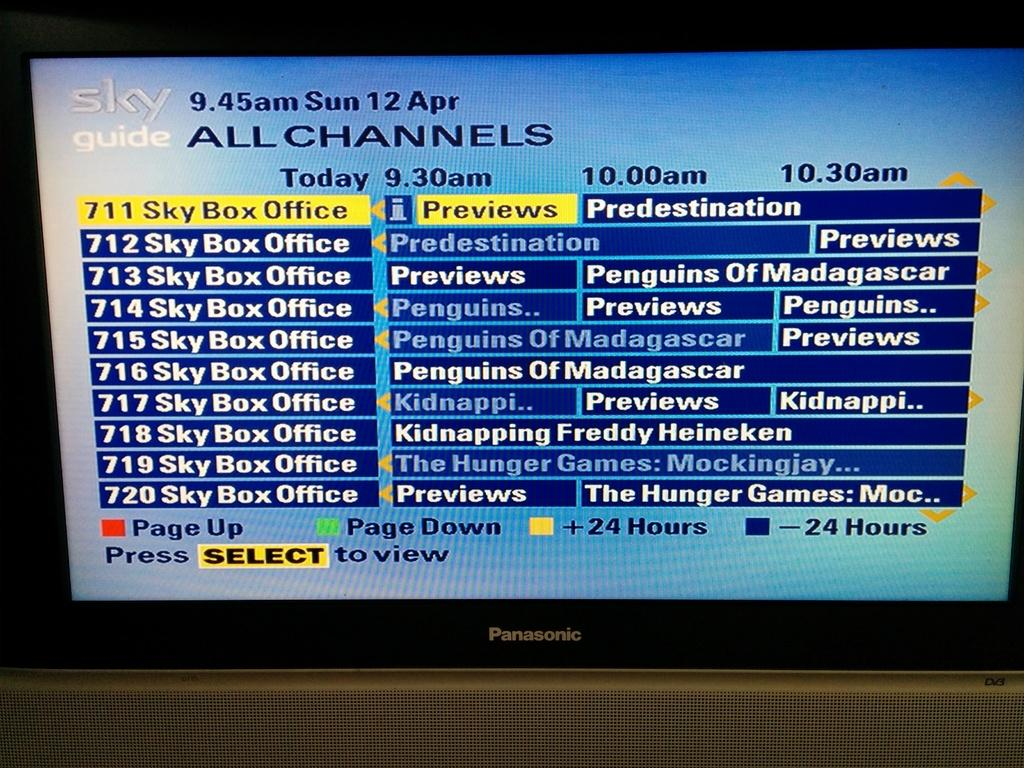<image>
Create a compact narrative representing the image presented. A TV screen has the words All channels on it. 